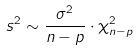Convert formula to latex. <formula><loc_0><loc_0><loc_500><loc_500>s ^ { 2 } \sim \frac { \sigma ^ { 2 } } { n - p } \cdot \chi _ { n - p } ^ { 2 }</formula> 